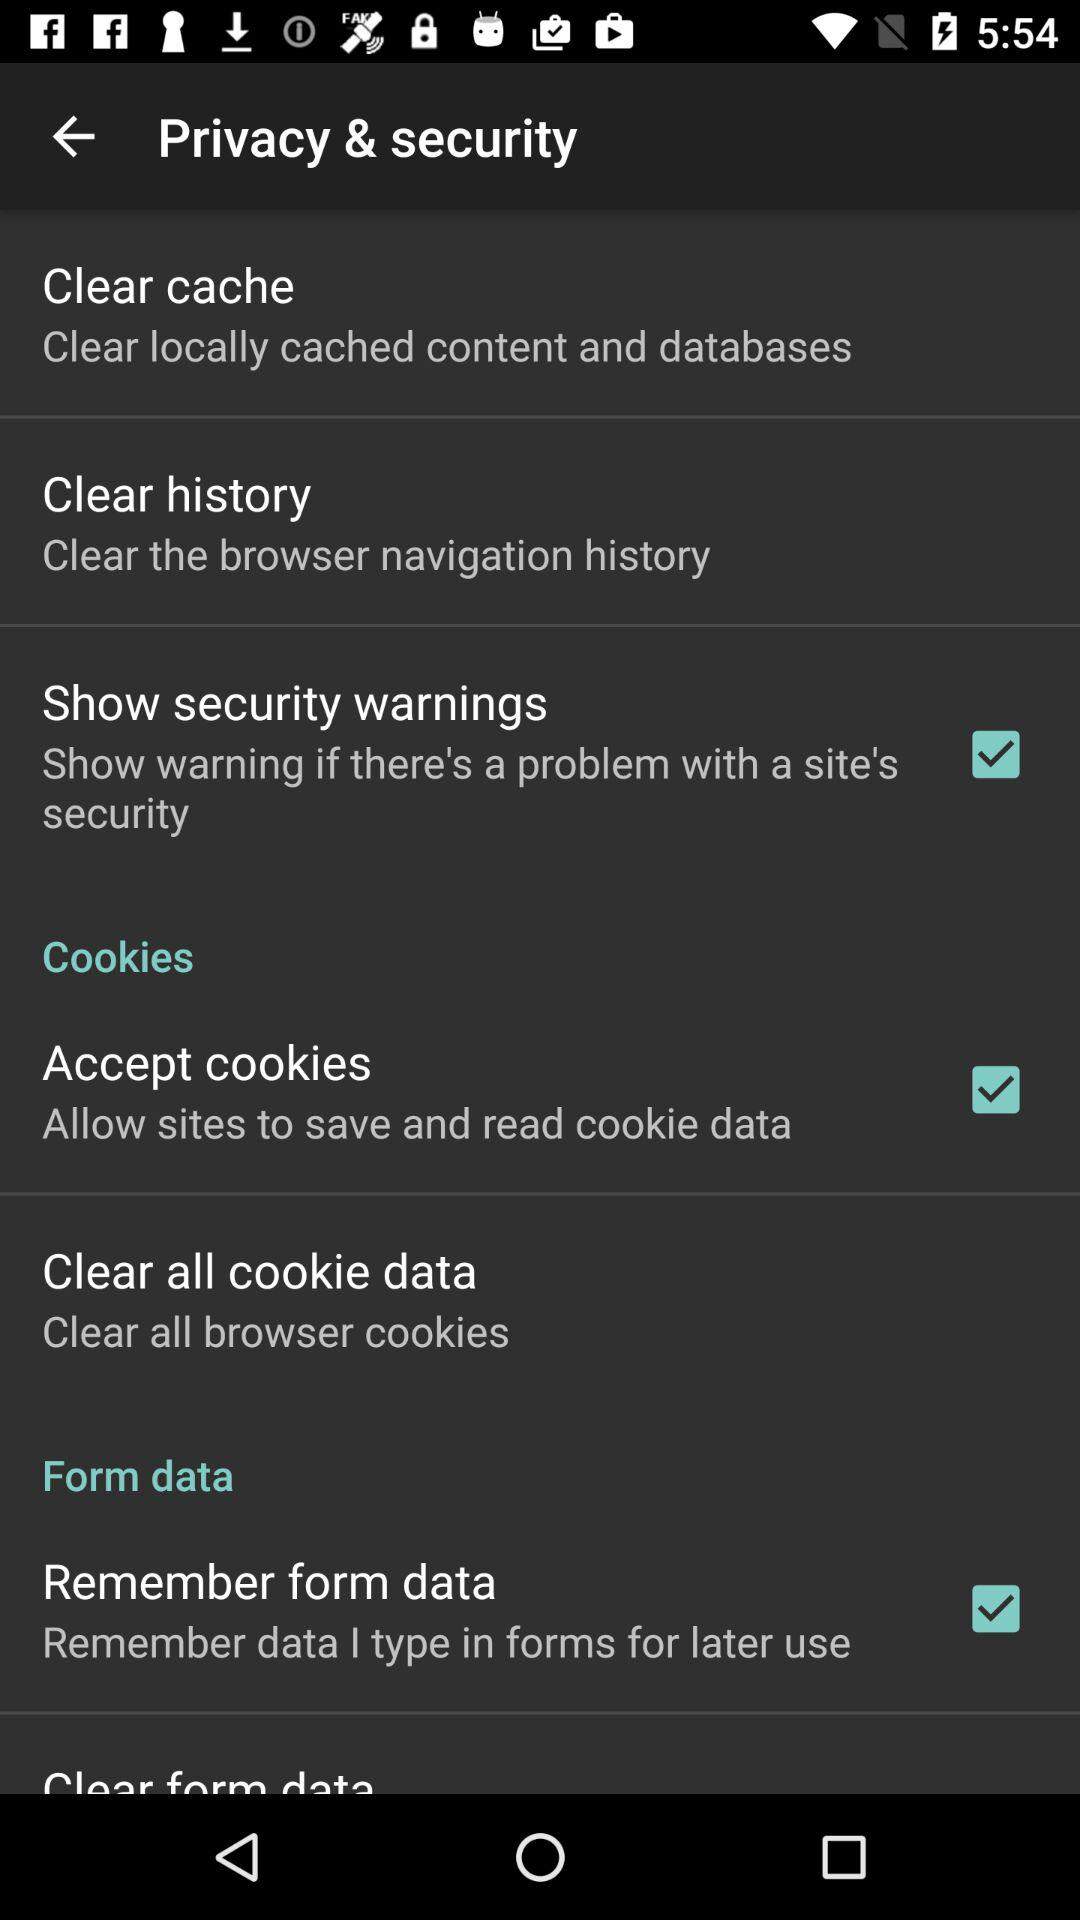What is the status of the "Accept cookies" setting? The status of the "Accept cookies" setting is "on". 